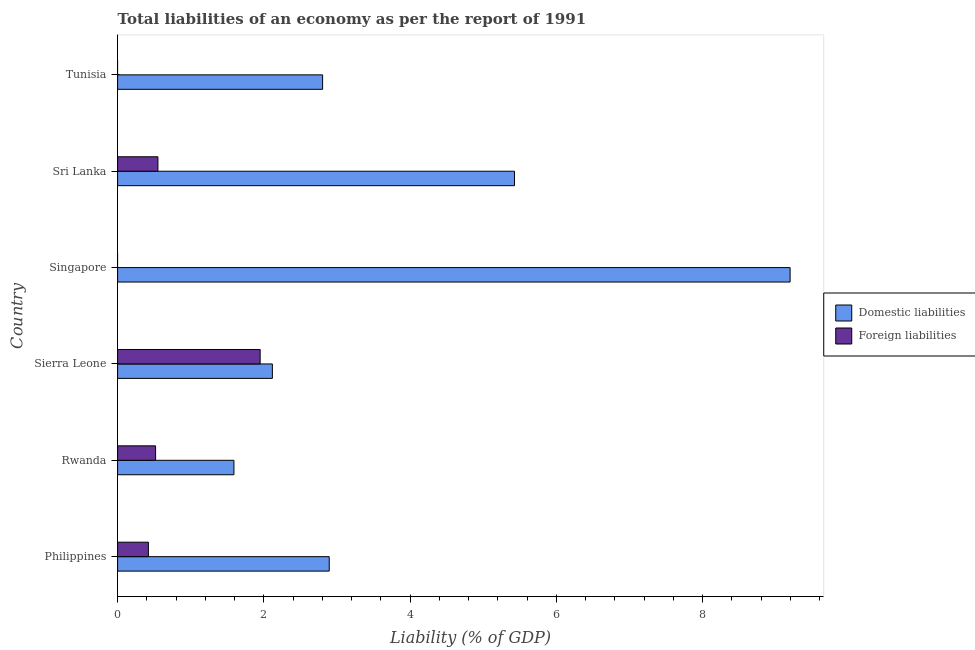How many different coloured bars are there?
Offer a terse response. 2. Are the number of bars per tick equal to the number of legend labels?
Offer a terse response. No. Are the number of bars on each tick of the Y-axis equal?
Offer a terse response. No. How many bars are there on the 5th tick from the top?
Offer a terse response. 2. What is the label of the 3rd group of bars from the top?
Provide a succinct answer. Singapore. What is the incurrence of domestic liabilities in Philippines?
Provide a short and direct response. 2.89. Across all countries, what is the maximum incurrence of domestic liabilities?
Keep it short and to the point. 9.2. Across all countries, what is the minimum incurrence of foreign liabilities?
Ensure brevity in your answer.  0. In which country was the incurrence of foreign liabilities maximum?
Make the answer very short. Sierra Leone. What is the total incurrence of foreign liabilities in the graph?
Provide a succinct answer. 3.44. What is the difference between the incurrence of domestic liabilities in Philippines and that in Sierra Leone?
Provide a succinct answer. 0.78. What is the difference between the incurrence of foreign liabilities in Philippines and the incurrence of domestic liabilities in Tunisia?
Your answer should be compact. -2.38. What is the average incurrence of domestic liabilities per country?
Your answer should be very brief. 4. What is the difference between the incurrence of domestic liabilities and incurrence of foreign liabilities in Sri Lanka?
Provide a succinct answer. 4.88. What is the ratio of the incurrence of foreign liabilities in Philippines to that in Sri Lanka?
Provide a succinct answer. 0.76. What is the difference between the highest and the second highest incurrence of foreign liabilities?
Your response must be concise. 1.4. What is the difference between the highest and the lowest incurrence of domestic liabilities?
Offer a very short reply. 7.61. In how many countries, is the incurrence of foreign liabilities greater than the average incurrence of foreign liabilities taken over all countries?
Offer a very short reply. 1. Is the sum of the incurrence of domestic liabilities in Sierra Leone and Tunisia greater than the maximum incurrence of foreign liabilities across all countries?
Keep it short and to the point. Yes. Are all the bars in the graph horizontal?
Offer a terse response. Yes. What is the title of the graph?
Ensure brevity in your answer.  Total liabilities of an economy as per the report of 1991. What is the label or title of the X-axis?
Ensure brevity in your answer.  Liability (% of GDP). What is the Liability (% of GDP) of Domestic liabilities in Philippines?
Offer a very short reply. 2.89. What is the Liability (% of GDP) of Foreign liabilities in Philippines?
Keep it short and to the point. 0.42. What is the Liability (% of GDP) of Domestic liabilities in Rwanda?
Your answer should be compact. 1.59. What is the Liability (% of GDP) of Foreign liabilities in Rwanda?
Your answer should be compact. 0.52. What is the Liability (% of GDP) of Domestic liabilities in Sierra Leone?
Your answer should be very brief. 2.12. What is the Liability (% of GDP) of Foreign liabilities in Sierra Leone?
Make the answer very short. 1.95. What is the Liability (% of GDP) in Domestic liabilities in Singapore?
Make the answer very short. 9.2. What is the Liability (% of GDP) in Domestic liabilities in Sri Lanka?
Your answer should be compact. 5.43. What is the Liability (% of GDP) of Foreign liabilities in Sri Lanka?
Provide a succinct answer. 0.55. What is the Liability (% of GDP) of Domestic liabilities in Tunisia?
Give a very brief answer. 2.8. What is the Liability (% of GDP) in Foreign liabilities in Tunisia?
Give a very brief answer. 0. Across all countries, what is the maximum Liability (% of GDP) of Domestic liabilities?
Your response must be concise. 9.2. Across all countries, what is the maximum Liability (% of GDP) in Foreign liabilities?
Keep it short and to the point. 1.95. Across all countries, what is the minimum Liability (% of GDP) of Domestic liabilities?
Keep it short and to the point. 1.59. What is the total Liability (% of GDP) of Domestic liabilities in the graph?
Offer a terse response. 24.03. What is the total Liability (% of GDP) of Foreign liabilities in the graph?
Your answer should be compact. 3.44. What is the difference between the Liability (% of GDP) in Domestic liabilities in Philippines and that in Rwanda?
Make the answer very short. 1.3. What is the difference between the Liability (% of GDP) in Foreign liabilities in Philippines and that in Rwanda?
Offer a terse response. -0.1. What is the difference between the Liability (% of GDP) in Domestic liabilities in Philippines and that in Sierra Leone?
Offer a terse response. 0.78. What is the difference between the Liability (% of GDP) of Foreign liabilities in Philippines and that in Sierra Leone?
Keep it short and to the point. -1.53. What is the difference between the Liability (% of GDP) in Domestic liabilities in Philippines and that in Singapore?
Offer a very short reply. -6.3. What is the difference between the Liability (% of GDP) of Domestic liabilities in Philippines and that in Sri Lanka?
Offer a very short reply. -2.53. What is the difference between the Liability (% of GDP) in Foreign liabilities in Philippines and that in Sri Lanka?
Your answer should be very brief. -0.13. What is the difference between the Liability (% of GDP) of Domestic liabilities in Philippines and that in Tunisia?
Your answer should be compact. 0.09. What is the difference between the Liability (% of GDP) in Domestic liabilities in Rwanda and that in Sierra Leone?
Keep it short and to the point. -0.53. What is the difference between the Liability (% of GDP) of Foreign liabilities in Rwanda and that in Sierra Leone?
Provide a short and direct response. -1.43. What is the difference between the Liability (% of GDP) in Domestic liabilities in Rwanda and that in Singapore?
Provide a short and direct response. -7.61. What is the difference between the Liability (% of GDP) of Domestic liabilities in Rwanda and that in Sri Lanka?
Make the answer very short. -3.84. What is the difference between the Liability (% of GDP) in Foreign liabilities in Rwanda and that in Sri Lanka?
Provide a short and direct response. -0.03. What is the difference between the Liability (% of GDP) of Domestic liabilities in Rwanda and that in Tunisia?
Offer a very short reply. -1.21. What is the difference between the Liability (% of GDP) of Domestic liabilities in Sierra Leone and that in Singapore?
Offer a terse response. -7.08. What is the difference between the Liability (% of GDP) of Domestic liabilities in Sierra Leone and that in Sri Lanka?
Your answer should be very brief. -3.31. What is the difference between the Liability (% of GDP) of Foreign liabilities in Sierra Leone and that in Sri Lanka?
Offer a very short reply. 1.4. What is the difference between the Liability (% of GDP) of Domestic liabilities in Sierra Leone and that in Tunisia?
Provide a succinct answer. -0.69. What is the difference between the Liability (% of GDP) in Domestic liabilities in Singapore and that in Sri Lanka?
Keep it short and to the point. 3.77. What is the difference between the Liability (% of GDP) in Domestic liabilities in Singapore and that in Tunisia?
Your response must be concise. 6.39. What is the difference between the Liability (% of GDP) in Domestic liabilities in Sri Lanka and that in Tunisia?
Your answer should be compact. 2.62. What is the difference between the Liability (% of GDP) of Domestic liabilities in Philippines and the Liability (% of GDP) of Foreign liabilities in Rwanda?
Provide a succinct answer. 2.37. What is the difference between the Liability (% of GDP) of Domestic liabilities in Philippines and the Liability (% of GDP) of Foreign liabilities in Sierra Leone?
Your answer should be very brief. 0.94. What is the difference between the Liability (% of GDP) in Domestic liabilities in Philippines and the Liability (% of GDP) in Foreign liabilities in Sri Lanka?
Your answer should be compact. 2.34. What is the difference between the Liability (% of GDP) of Domestic liabilities in Rwanda and the Liability (% of GDP) of Foreign liabilities in Sierra Leone?
Keep it short and to the point. -0.36. What is the difference between the Liability (% of GDP) of Domestic liabilities in Rwanda and the Liability (% of GDP) of Foreign liabilities in Sri Lanka?
Your response must be concise. 1.04. What is the difference between the Liability (% of GDP) in Domestic liabilities in Sierra Leone and the Liability (% of GDP) in Foreign liabilities in Sri Lanka?
Make the answer very short. 1.56. What is the difference between the Liability (% of GDP) in Domestic liabilities in Singapore and the Liability (% of GDP) in Foreign liabilities in Sri Lanka?
Keep it short and to the point. 8.64. What is the average Liability (% of GDP) of Domestic liabilities per country?
Keep it short and to the point. 4. What is the average Liability (% of GDP) in Foreign liabilities per country?
Keep it short and to the point. 0.57. What is the difference between the Liability (% of GDP) in Domestic liabilities and Liability (% of GDP) in Foreign liabilities in Philippines?
Offer a terse response. 2.47. What is the difference between the Liability (% of GDP) of Domestic liabilities and Liability (% of GDP) of Foreign liabilities in Rwanda?
Ensure brevity in your answer.  1.07. What is the difference between the Liability (% of GDP) in Domestic liabilities and Liability (% of GDP) in Foreign liabilities in Sierra Leone?
Your answer should be very brief. 0.17. What is the difference between the Liability (% of GDP) of Domestic liabilities and Liability (% of GDP) of Foreign liabilities in Sri Lanka?
Give a very brief answer. 4.88. What is the ratio of the Liability (% of GDP) of Domestic liabilities in Philippines to that in Rwanda?
Provide a short and direct response. 1.82. What is the ratio of the Liability (% of GDP) in Foreign liabilities in Philippines to that in Rwanda?
Keep it short and to the point. 0.81. What is the ratio of the Liability (% of GDP) in Domestic liabilities in Philippines to that in Sierra Leone?
Make the answer very short. 1.37. What is the ratio of the Liability (% of GDP) of Foreign liabilities in Philippines to that in Sierra Leone?
Provide a succinct answer. 0.22. What is the ratio of the Liability (% of GDP) of Domestic liabilities in Philippines to that in Singapore?
Offer a very short reply. 0.31. What is the ratio of the Liability (% of GDP) in Domestic liabilities in Philippines to that in Sri Lanka?
Offer a very short reply. 0.53. What is the ratio of the Liability (% of GDP) of Foreign liabilities in Philippines to that in Sri Lanka?
Provide a short and direct response. 0.76. What is the ratio of the Liability (% of GDP) of Domestic liabilities in Philippines to that in Tunisia?
Give a very brief answer. 1.03. What is the ratio of the Liability (% of GDP) in Domestic liabilities in Rwanda to that in Sierra Leone?
Keep it short and to the point. 0.75. What is the ratio of the Liability (% of GDP) in Foreign liabilities in Rwanda to that in Sierra Leone?
Your answer should be very brief. 0.27. What is the ratio of the Liability (% of GDP) of Domestic liabilities in Rwanda to that in Singapore?
Offer a terse response. 0.17. What is the ratio of the Liability (% of GDP) in Domestic liabilities in Rwanda to that in Sri Lanka?
Your answer should be very brief. 0.29. What is the ratio of the Liability (% of GDP) in Foreign liabilities in Rwanda to that in Sri Lanka?
Ensure brevity in your answer.  0.94. What is the ratio of the Liability (% of GDP) in Domestic liabilities in Rwanda to that in Tunisia?
Keep it short and to the point. 0.57. What is the ratio of the Liability (% of GDP) in Domestic liabilities in Sierra Leone to that in Singapore?
Make the answer very short. 0.23. What is the ratio of the Liability (% of GDP) of Domestic liabilities in Sierra Leone to that in Sri Lanka?
Your answer should be compact. 0.39. What is the ratio of the Liability (% of GDP) of Foreign liabilities in Sierra Leone to that in Sri Lanka?
Offer a very short reply. 3.54. What is the ratio of the Liability (% of GDP) of Domestic liabilities in Sierra Leone to that in Tunisia?
Your answer should be very brief. 0.75. What is the ratio of the Liability (% of GDP) in Domestic liabilities in Singapore to that in Sri Lanka?
Offer a terse response. 1.69. What is the ratio of the Liability (% of GDP) in Domestic liabilities in Singapore to that in Tunisia?
Ensure brevity in your answer.  3.28. What is the ratio of the Liability (% of GDP) of Domestic liabilities in Sri Lanka to that in Tunisia?
Your answer should be compact. 1.94. What is the difference between the highest and the second highest Liability (% of GDP) of Domestic liabilities?
Offer a terse response. 3.77. What is the difference between the highest and the second highest Liability (% of GDP) in Foreign liabilities?
Give a very brief answer. 1.4. What is the difference between the highest and the lowest Liability (% of GDP) of Domestic liabilities?
Make the answer very short. 7.61. What is the difference between the highest and the lowest Liability (% of GDP) of Foreign liabilities?
Provide a succinct answer. 1.95. 